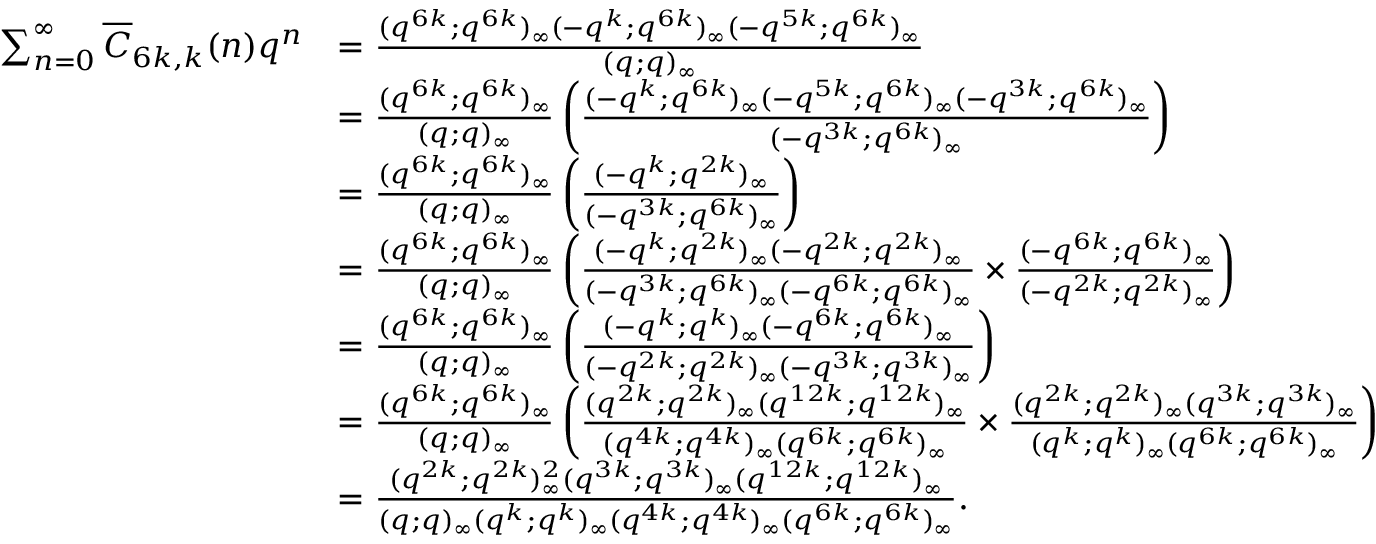<formula> <loc_0><loc_0><loc_500><loc_500>\begin{array} { r l } { \sum _ { n = 0 } ^ { \infty } \overline { C } _ { 6 k , k } ( n ) q ^ { n } } & { = \frac { ( q ^ { 6 k } ; q ^ { 6 k } ) _ { \infty } ( - q ^ { k } ; q ^ { 6 k } ) _ { \infty } ( - q ^ { 5 k } ; q ^ { 6 k } ) _ { \infty } } { ( q ; q ) _ { \infty } } } \\ & { = \frac { ( q ^ { 6 k } ; q ^ { 6 k } ) _ { \infty } } { ( q ; q ) _ { \infty } } \left ( \frac { ( - q ^ { k } ; q ^ { 6 k } ) _ { \infty } ( - q ^ { 5 k } ; q ^ { 6 k } ) _ { \infty } ( - q ^ { 3 k } ; q ^ { 6 k } ) _ { \infty } } { ( - q ^ { 3 k } ; q ^ { 6 k } ) _ { \infty } } \right ) } \\ & { = \frac { ( q ^ { 6 k } ; q ^ { 6 k } ) _ { \infty } } { ( q ; q ) _ { \infty } } \left ( \frac { ( - q ^ { k } ; q ^ { 2 k } ) _ { \infty } } { ( - q ^ { 3 k } ; q ^ { 6 k } ) _ { \infty } } \right ) } \\ & { = \frac { ( q ^ { 6 k } ; q ^ { 6 k } ) _ { \infty } } { ( q ; q ) _ { \infty } } \left ( \frac { ( - q ^ { k } ; q ^ { 2 k } ) _ { \infty } ( - q ^ { 2 k } ; q ^ { 2 k } ) _ { \infty } } { ( - q ^ { 3 k } ; q ^ { 6 k } ) _ { \infty } ( - q ^ { 6 k } ; q ^ { 6 k } ) _ { \infty } } \times \frac { ( - q ^ { 6 k } ; q ^ { 6 k } ) _ { \infty } } { ( - q ^ { 2 k } ; q ^ { 2 k } ) _ { \infty } } \right ) } \\ & { = \frac { ( q ^ { 6 k } ; q ^ { 6 k } ) _ { \infty } } { ( q ; q ) _ { \infty } } \left ( \frac { ( - q ^ { k } ; q ^ { k } ) _ { \infty } ( - q ^ { 6 k } ; q ^ { 6 k } ) _ { \infty } } { ( - q ^ { 2 k } ; q ^ { 2 k } ) _ { \infty } ( - q ^ { 3 k } ; q ^ { 3 k } ) _ { \infty } } \right ) } \\ & { = \frac { ( q ^ { 6 k } ; q ^ { 6 k } ) _ { \infty } } { ( q ; q ) _ { \infty } } \left ( \frac { ( q ^ { 2 k } ; q ^ { 2 k } ) _ { \infty } ( q ^ { 1 2 k } ; q ^ { 1 2 k } ) _ { \infty } } { ( q ^ { 4 k } ; q ^ { 4 k } ) _ { \infty } ( q ^ { 6 k } ; q ^ { 6 k } ) _ { \infty } } \times \frac { ( q ^ { 2 k } ; q ^ { 2 k } ) _ { \infty } ( q ^ { 3 k } ; q ^ { 3 k } ) _ { \infty } } { ( q ^ { k } ; q ^ { k } ) _ { \infty } ( q ^ { 6 k } ; q ^ { 6 k } ) _ { \infty } } \right ) } \\ & { = \frac { ( q ^ { 2 k } ; q ^ { 2 k } ) _ { \infty } ^ { 2 } ( q ^ { 3 k } ; q ^ { 3 k } ) _ { \infty } ( q ^ { 1 2 k } ; q ^ { 1 2 k } ) _ { \infty } } { ( q ; q ) _ { \infty } ( q ^ { k } ; q ^ { k } ) _ { \infty } ( q ^ { 4 k } ; q ^ { 4 k } ) _ { \infty } ( q ^ { 6 k } ; q ^ { 6 k } ) _ { \infty } } . } \end{array}</formula> 